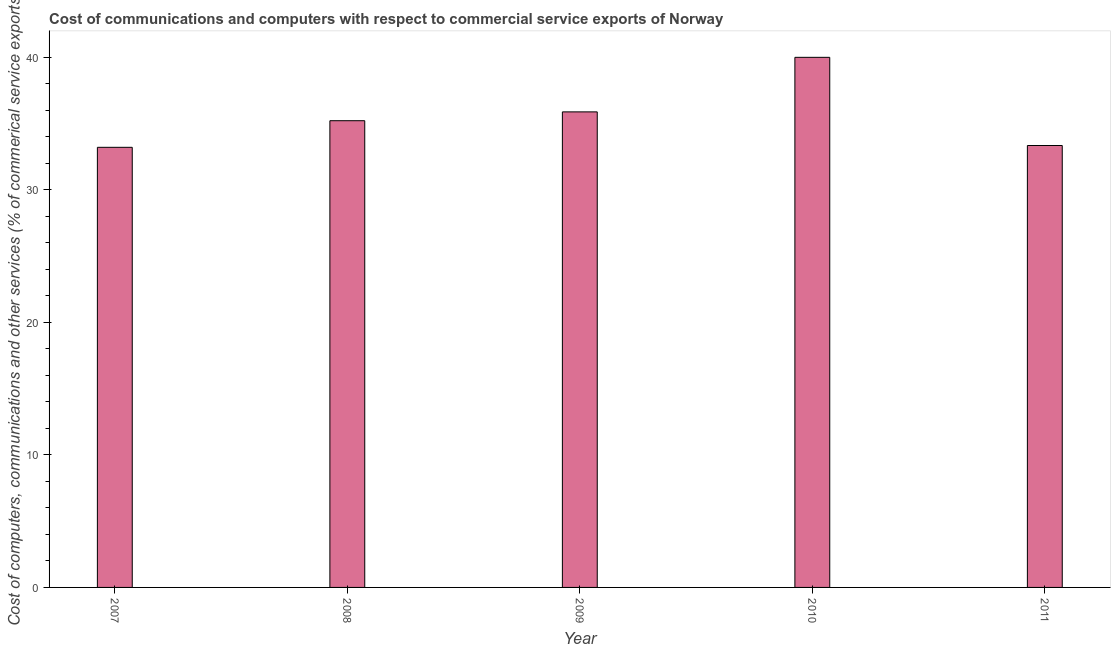What is the title of the graph?
Your response must be concise. Cost of communications and computers with respect to commercial service exports of Norway. What is the label or title of the X-axis?
Provide a succinct answer. Year. What is the label or title of the Y-axis?
Offer a terse response. Cost of computers, communications and other services (% of commerical service exports). What is the cost of communications in 2010?
Keep it short and to the point. 39.99. Across all years, what is the maximum cost of communications?
Provide a short and direct response. 39.99. Across all years, what is the minimum cost of communications?
Your response must be concise. 33.2. In which year was the  computer and other services maximum?
Keep it short and to the point. 2010. In which year was the cost of communications minimum?
Offer a terse response. 2007. What is the sum of the  computer and other services?
Your answer should be compact. 177.63. What is the difference between the  computer and other services in 2010 and 2011?
Make the answer very short. 6.65. What is the average cost of communications per year?
Provide a succinct answer. 35.53. What is the median  computer and other services?
Your response must be concise. 35.21. What is the ratio of the cost of communications in 2008 to that in 2010?
Ensure brevity in your answer.  0.88. Is the  computer and other services in 2008 less than that in 2011?
Offer a terse response. No. What is the difference between the highest and the second highest  computer and other services?
Your response must be concise. 4.12. Is the sum of the  computer and other services in 2007 and 2010 greater than the maximum  computer and other services across all years?
Ensure brevity in your answer.  Yes. What is the difference between the highest and the lowest cost of communications?
Provide a succinct answer. 6.79. In how many years, is the cost of communications greater than the average cost of communications taken over all years?
Offer a terse response. 2. How many bars are there?
Provide a succinct answer. 5. What is the difference between two consecutive major ticks on the Y-axis?
Offer a very short reply. 10. Are the values on the major ticks of Y-axis written in scientific E-notation?
Your answer should be very brief. No. What is the Cost of computers, communications and other services (% of commerical service exports) of 2007?
Your answer should be compact. 33.2. What is the Cost of computers, communications and other services (% of commerical service exports) in 2008?
Make the answer very short. 35.21. What is the Cost of computers, communications and other services (% of commerical service exports) of 2009?
Give a very brief answer. 35.88. What is the Cost of computers, communications and other services (% of commerical service exports) in 2010?
Your answer should be compact. 39.99. What is the Cost of computers, communications and other services (% of commerical service exports) of 2011?
Ensure brevity in your answer.  33.34. What is the difference between the Cost of computers, communications and other services (% of commerical service exports) in 2007 and 2008?
Provide a succinct answer. -2.01. What is the difference between the Cost of computers, communications and other services (% of commerical service exports) in 2007 and 2009?
Your answer should be very brief. -2.67. What is the difference between the Cost of computers, communications and other services (% of commerical service exports) in 2007 and 2010?
Your answer should be compact. -6.79. What is the difference between the Cost of computers, communications and other services (% of commerical service exports) in 2007 and 2011?
Your answer should be very brief. -0.14. What is the difference between the Cost of computers, communications and other services (% of commerical service exports) in 2008 and 2009?
Provide a succinct answer. -0.67. What is the difference between the Cost of computers, communications and other services (% of commerical service exports) in 2008 and 2010?
Ensure brevity in your answer.  -4.78. What is the difference between the Cost of computers, communications and other services (% of commerical service exports) in 2008 and 2011?
Give a very brief answer. 1.87. What is the difference between the Cost of computers, communications and other services (% of commerical service exports) in 2009 and 2010?
Give a very brief answer. -4.12. What is the difference between the Cost of computers, communications and other services (% of commerical service exports) in 2009 and 2011?
Make the answer very short. 2.54. What is the difference between the Cost of computers, communications and other services (% of commerical service exports) in 2010 and 2011?
Give a very brief answer. 6.65. What is the ratio of the Cost of computers, communications and other services (% of commerical service exports) in 2007 to that in 2008?
Ensure brevity in your answer.  0.94. What is the ratio of the Cost of computers, communications and other services (% of commerical service exports) in 2007 to that in 2009?
Keep it short and to the point. 0.93. What is the ratio of the Cost of computers, communications and other services (% of commerical service exports) in 2007 to that in 2010?
Your answer should be very brief. 0.83. What is the ratio of the Cost of computers, communications and other services (% of commerical service exports) in 2008 to that in 2011?
Give a very brief answer. 1.06. What is the ratio of the Cost of computers, communications and other services (% of commerical service exports) in 2009 to that in 2010?
Make the answer very short. 0.9. What is the ratio of the Cost of computers, communications and other services (% of commerical service exports) in 2009 to that in 2011?
Give a very brief answer. 1.08. 